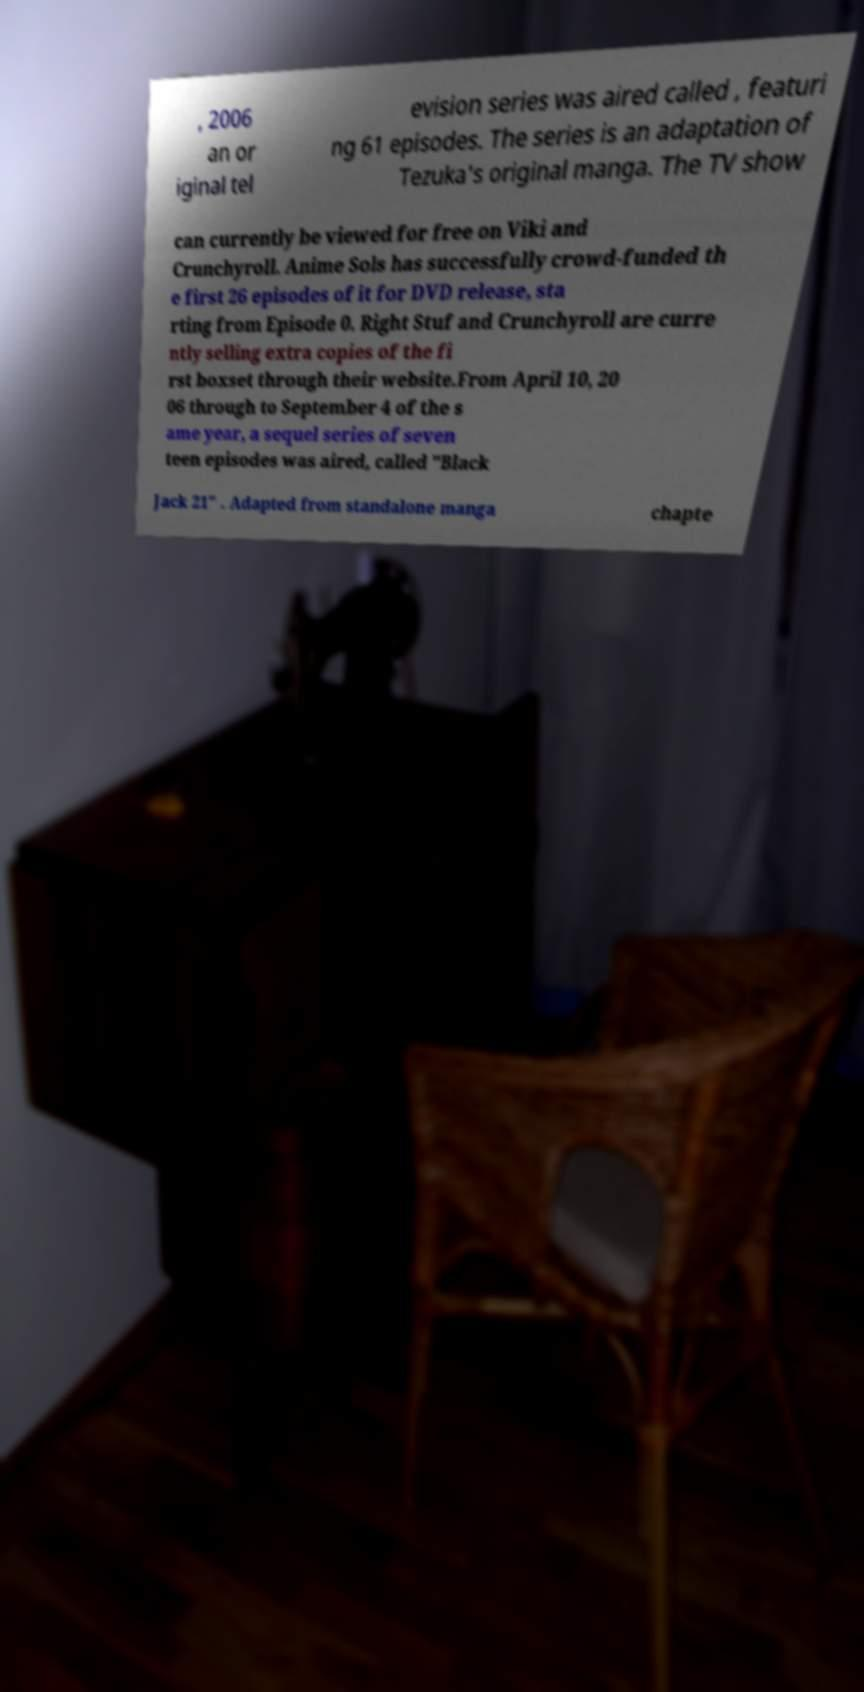For documentation purposes, I need the text within this image transcribed. Could you provide that? , 2006 an or iginal tel evision series was aired called , featuri ng 61 episodes. The series is an adaptation of Tezuka's original manga. The TV show can currently be viewed for free on Viki and Crunchyroll. Anime Sols has successfully crowd-funded th e first 26 episodes of it for DVD release, sta rting from Episode 0. Right Stuf and Crunchyroll are curre ntly selling extra copies of the fi rst boxset through their website.From April 10, 20 06 through to September 4 of the s ame year, a sequel series of seven teen episodes was aired, called "Black Jack 21" . Adapted from standalone manga chapte 